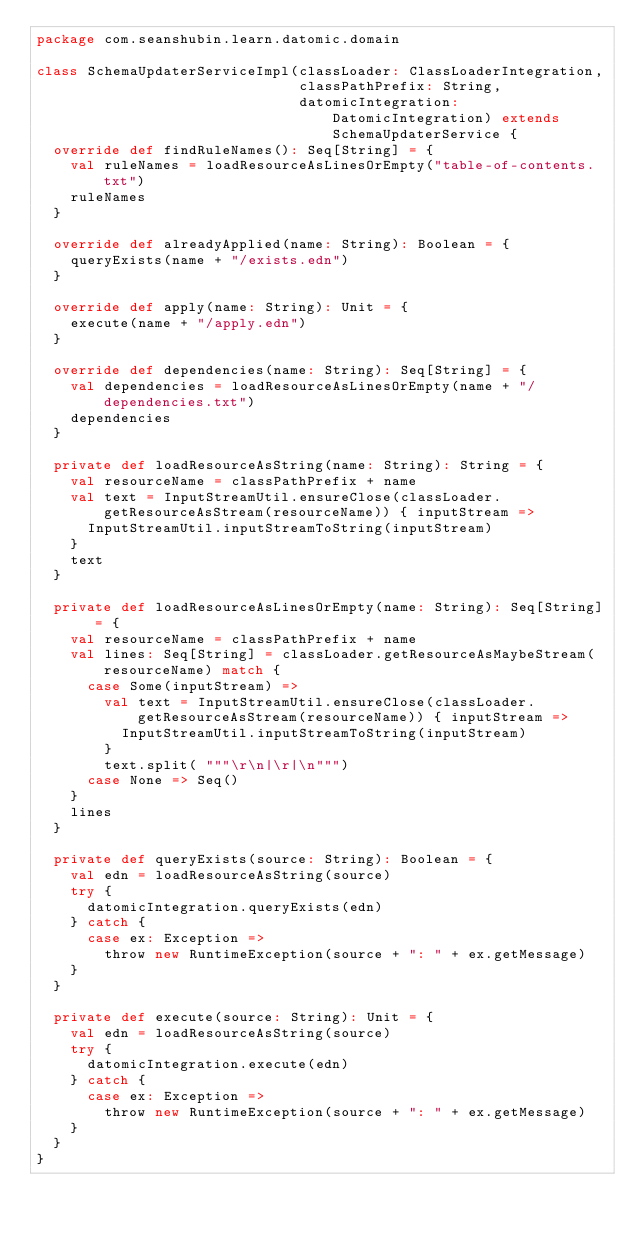Convert code to text. <code><loc_0><loc_0><loc_500><loc_500><_Scala_>package com.seanshubin.learn.datomic.domain

class SchemaUpdaterServiceImpl(classLoader: ClassLoaderIntegration,
                               classPathPrefix: String,
                               datomicIntegration: DatomicIntegration) extends SchemaUpdaterService {
  override def findRuleNames(): Seq[String] = {
    val ruleNames = loadResourceAsLinesOrEmpty("table-of-contents.txt")
    ruleNames
  }

  override def alreadyApplied(name: String): Boolean = {
    queryExists(name + "/exists.edn")
  }

  override def apply(name: String): Unit = {
    execute(name + "/apply.edn")
  }

  override def dependencies(name: String): Seq[String] = {
    val dependencies = loadResourceAsLinesOrEmpty(name + "/dependencies.txt")
    dependencies
  }

  private def loadResourceAsString(name: String): String = {
    val resourceName = classPathPrefix + name
    val text = InputStreamUtil.ensureClose(classLoader.getResourceAsStream(resourceName)) { inputStream =>
      InputStreamUtil.inputStreamToString(inputStream)
    }
    text
  }

  private def loadResourceAsLinesOrEmpty(name: String): Seq[String] = {
    val resourceName = classPathPrefix + name
    val lines: Seq[String] = classLoader.getResourceAsMaybeStream(resourceName) match {
      case Some(inputStream) =>
        val text = InputStreamUtil.ensureClose(classLoader.getResourceAsStream(resourceName)) { inputStream =>
          InputStreamUtil.inputStreamToString(inputStream)
        }
        text.split( """\r\n|\r|\n""")
      case None => Seq()
    }
    lines
  }

  private def queryExists(source: String): Boolean = {
    val edn = loadResourceAsString(source)
    try {
      datomicIntegration.queryExists(edn)
    } catch {
      case ex: Exception =>
        throw new RuntimeException(source + ": " + ex.getMessage)
    }
  }

  private def execute(source: String): Unit = {
    val edn = loadResourceAsString(source)
    try {
      datomicIntegration.execute(edn)
    } catch {
      case ex: Exception =>
        throw new RuntimeException(source + ": " + ex.getMessage)
    }
  }
}
</code> 